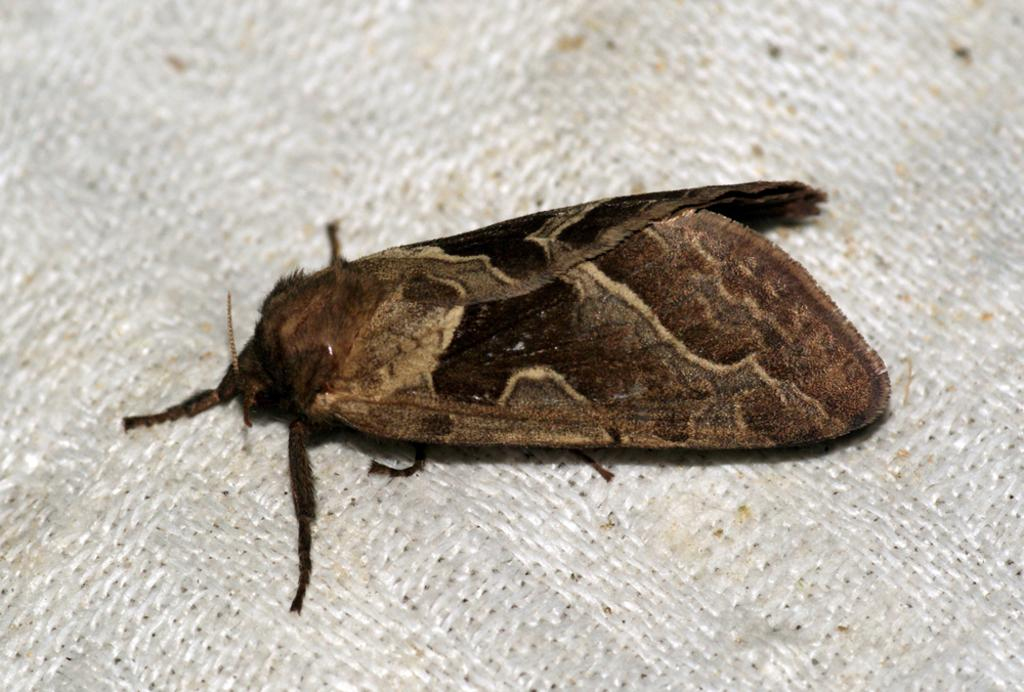What type of creature is in the image? There is an insect in the image. What colors can be seen on the insect? The insect has brown and cream colors. What is the insect resting on in the image? The insect is on a cream-colored surface. How many cats are interacting with the machine in the image? There are no cats or machines present in the image; it features an insect on a cream-colored surface. 